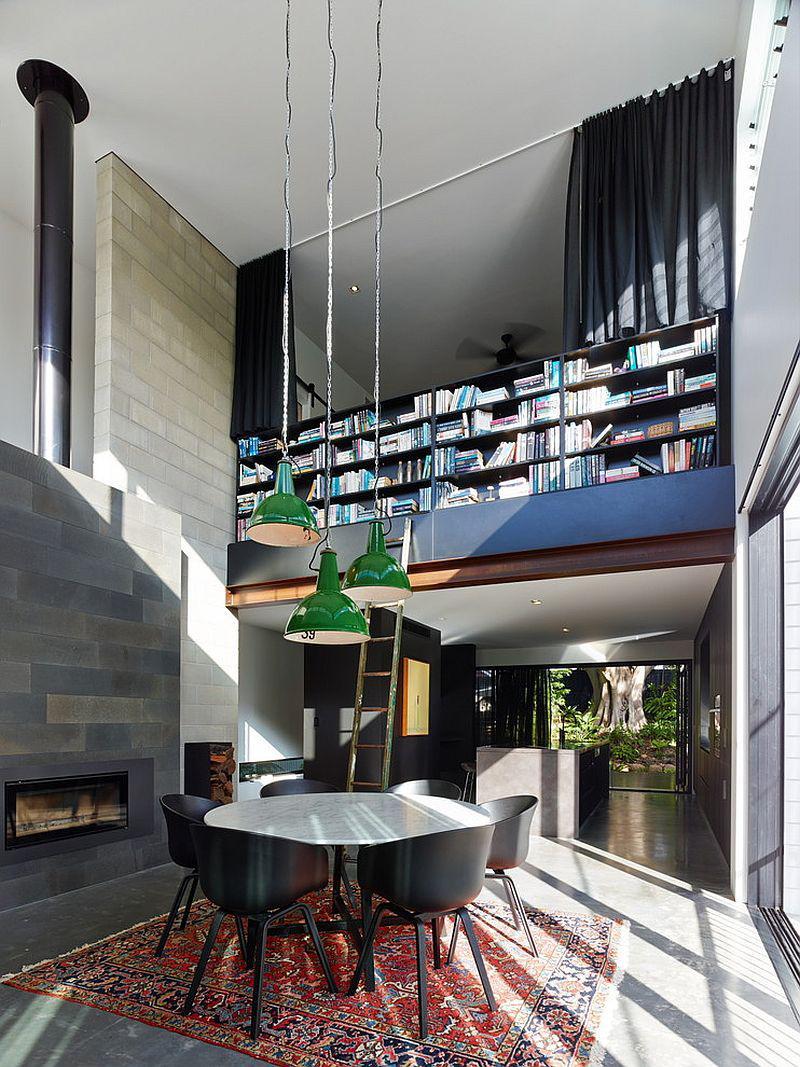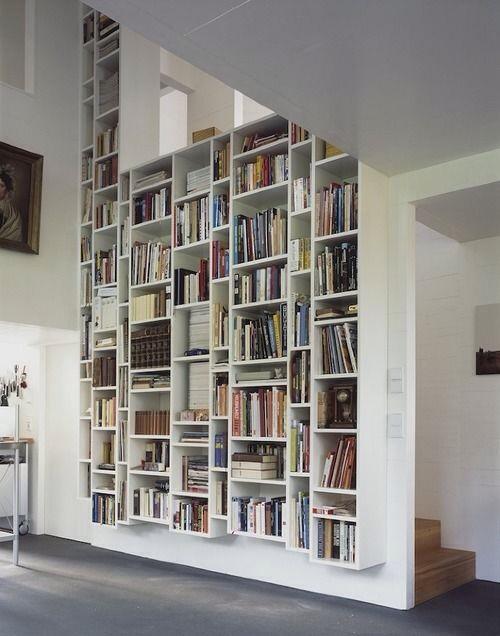The first image is the image on the left, the second image is the image on the right. For the images shown, is this caption "The reading are in the image on the right includes seating near a window." true? Answer yes or no. No. 